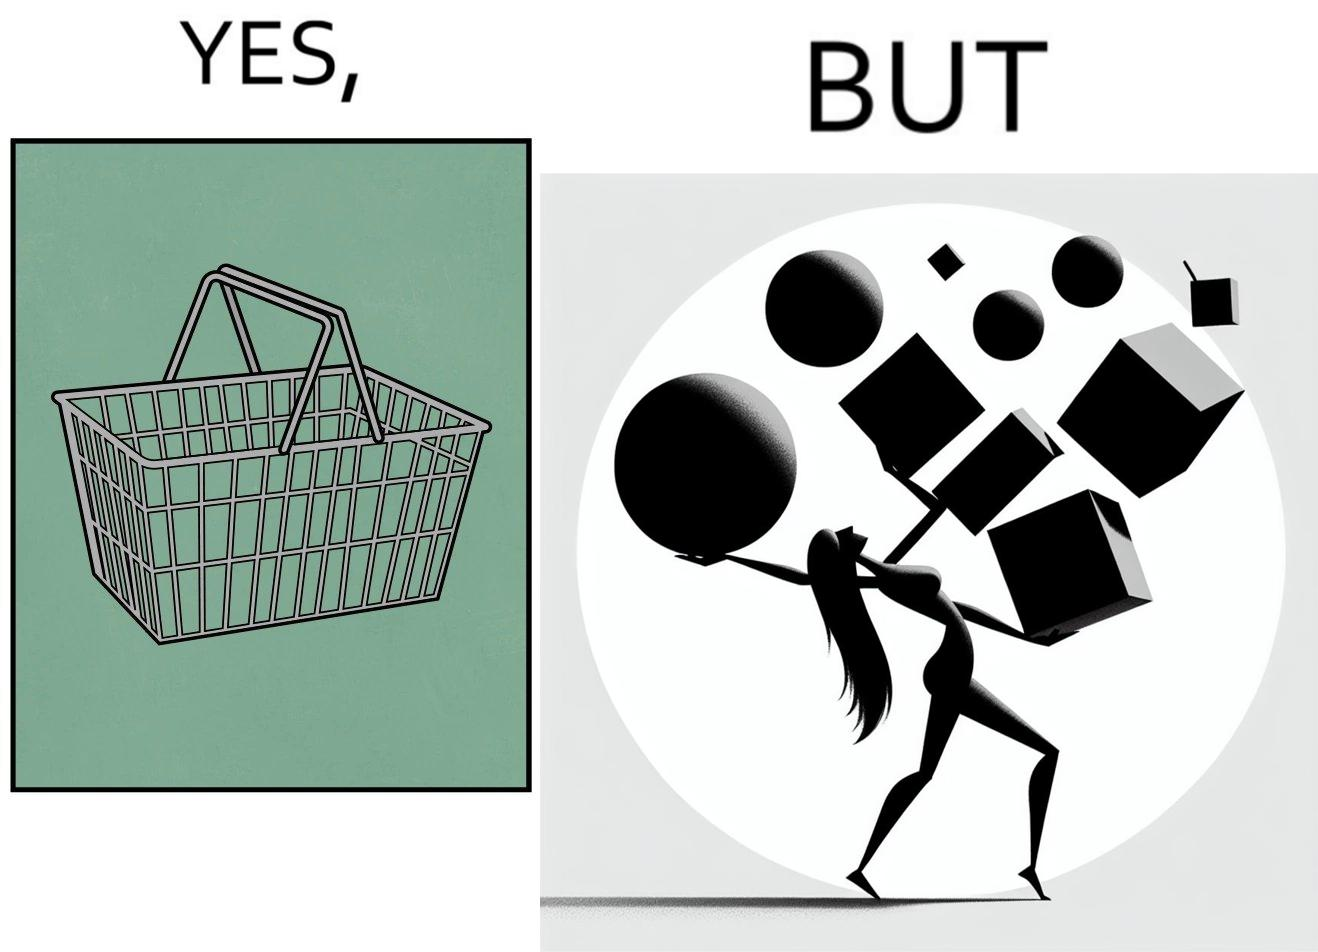What is shown in this image? The image is ironic, because even when there are steel frame baskets are available at the supermarkets people prefer carrying the items in hand 